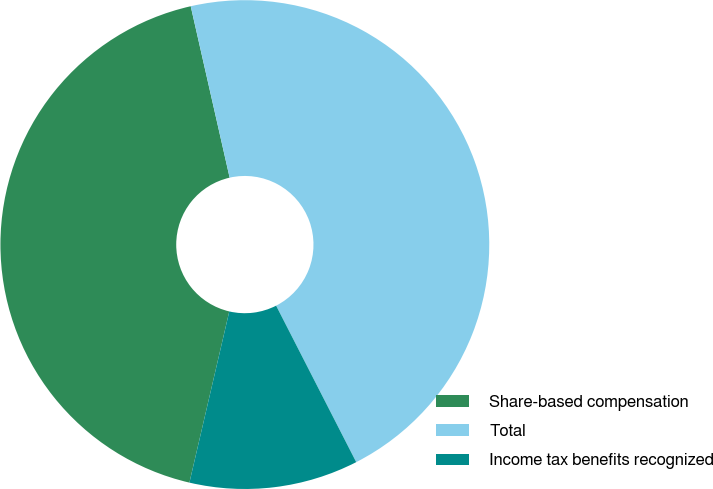Convert chart to OTSL. <chart><loc_0><loc_0><loc_500><loc_500><pie_chart><fcel>Share-based compensation<fcel>Total<fcel>Income tax benefits recognized<nl><fcel>42.8%<fcel>46.02%<fcel>11.17%<nl></chart> 